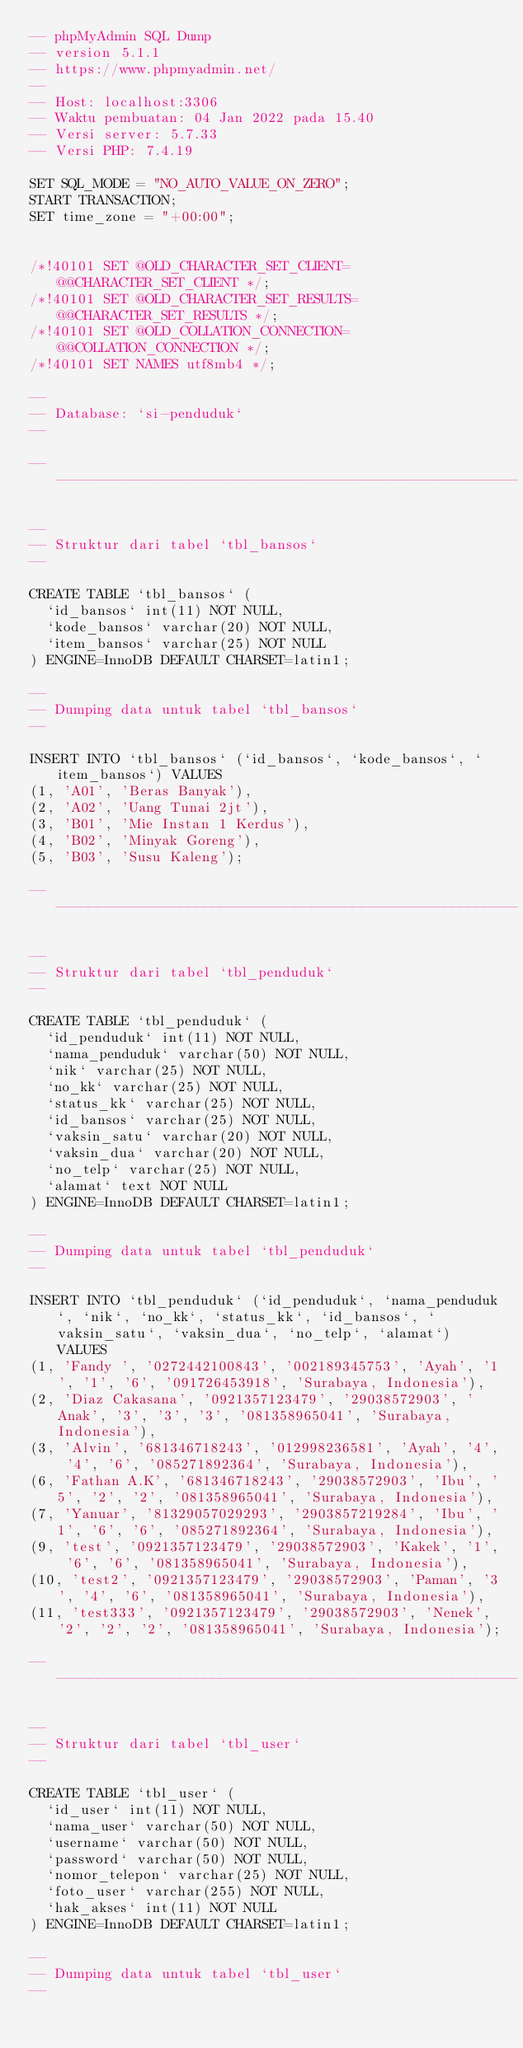Convert code to text. <code><loc_0><loc_0><loc_500><loc_500><_SQL_>-- phpMyAdmin SQL Dump
-- version 5.1.1
-- https://www.phpmyadmin.net/
--
-- Host: localhost:3306
-- Waktu pembuatan: 04 Jan 2022 pada 15.40
-- Versi server: 5.7.33
-- Versi PHP: 7.4.19

SET SQL_MODE = "NO_AUTO_VALUE_ON_ZERO";
START TRANSACTION;
SET time_zone = "+00:00";


/*!40101 SET @OLD_CHARACTER_SET_CLIENT=@@CHARACTER_SET_CLIENT */;
/*!40101 SET @OLD_CHARACTER_SET_RESULTS=@@CHARACTER_SET_RESULTS */;
/*!40101 SET @OLD_COLLATION_CONNECTION=@@COLLATION_CONNECTION */;
/*!40101 SET NAMES utf8mb4 */;

--
-- Database: `si-penduduk`
--

-- --------------------------------------------------------

--
-- Struktur dari tabel `tbl_bansos`
--

CREATE TABLE `tbl_bansos` (
  `id_bansos` int(11) NOT NULL,
  `kode_bansos` varchar(20) NOT NULL,
  `item_bansos` varchar(25) NOT NULL
) ENGINE=InnoDB DEFAULT CHARSET=latin1;

--
-- Dumping data untuk tabel `tbl_bansos`
--

INSERT INTO `tbl_bansos` (`id_bansos`, `kode_bansos`, `item_bansos`) VALUES
(1, 'A01', 'Beras Banyak'),
(2, 'A02', 'Uang Tunai 2jt'),
(3, 'B01', 'Mie Instan 1 Kerdus'),
(4, 'B02', 'Minyak Goreng'),
(5, 'B03', 'Susu Kaleng');

-- --------------------------------------------------------

--
-- Struktur dari tabel `tbl_penduduk`
--

CREATE TABLE `tbl_penduduk` (
  `id_penduduk` int(11) NOT NULL,
  `nama_penduduk` varchar(50) NOT NULL,
  `nik` varchar(25) NOT NULL,
  `no_kk` varchar(25) NOT NULL,
  `status_kk` varchar(25) NOT NULL,
  `id_bansos` varchar(25) NOT NULL,
  `vaksin_satu` varchar(20) NOT NULL,
  `vaksin_dua` varchar(20) NOT NULL,
  `no_telp` varchar(25) NOT NULL,
  `alamat` text NOT NULL
) ENGINE=InnoDB DEFAULT CHARSET=latin1;

--
-- Dumping data untuk tabel `tbl_penduduk`
--

INSERT INTO `tbl_penduduk` (`id_penduduk`, `nama_penduduk`, `nik`, `no_kk`, `status_kk`, `id_bansos`, `vaksin_satu`, `vaksin_dua`, `no_telp`, `alamat`) VALUES
(1, 'Fandy ', '0272442100843', '002189345753', 'Ayah', '1', '1', '6', '091726453918', 'Surabaya, Indonesia'),
(2, 'Diaz Cakasana', '0921357123479', '29038572903', 'Anak', '3', '3', '3', '081358965041', 'Surabaya, Indonesia'),
(3, 'Alvin', '681346718243', '012998236581', 'Ayah', '4', '4', '6', '085271892364', 'Surabaya, Indonesia'),
(6, 'Fathan A.K', '681346718243', '29038572903', 'Ibu', '5', '2', '2', '081358965041', 'Surabaya, Indonesia'),
(7, 'Yanuar', '81329057029293', '2903857219284', 'Ibu', '1', '6', '6', '085271892364', 'Surabaya, Indonesia'),
(9, 'test', '0921357123479', '29038572903', 'Kakek', '1', '6', '6', '081358965041', 'Surabaya, Indonesia'),
(10, 'test2', '0921357123479', '29038572903', 'Paman', '3', '4', '6', '081358965041', 'Surabaya, Indonesia'),
(11, 'test333', '0921357123479', '29038572903', 'Nenek', '2', '2', '2', '081358965041', 'Surabaya, Indonesia');

-- --------------------------------------------------------

--
-- Struktur dari tabel `tbl_user`
--

CREATE TABLE `tbl_user` (
  `id_user` int(11) NOT NULL,
  `nama_user` varchar(50) NOT NULL,
  `username` varchar(50) NOT NULL,
  `password` varchar(50) NOT NULL,
  `nomor_telepon` varchar(25) NOT NULL,
  `foto_user` varchar(255) NOT NULL,
  `hak_akses` int(11) NOT NULL
) ENGINE=InnoDB DEFAULT CHARSET=latin1;

--
-- Dumping data untuk tabel `tbl_user`
--
</code> 